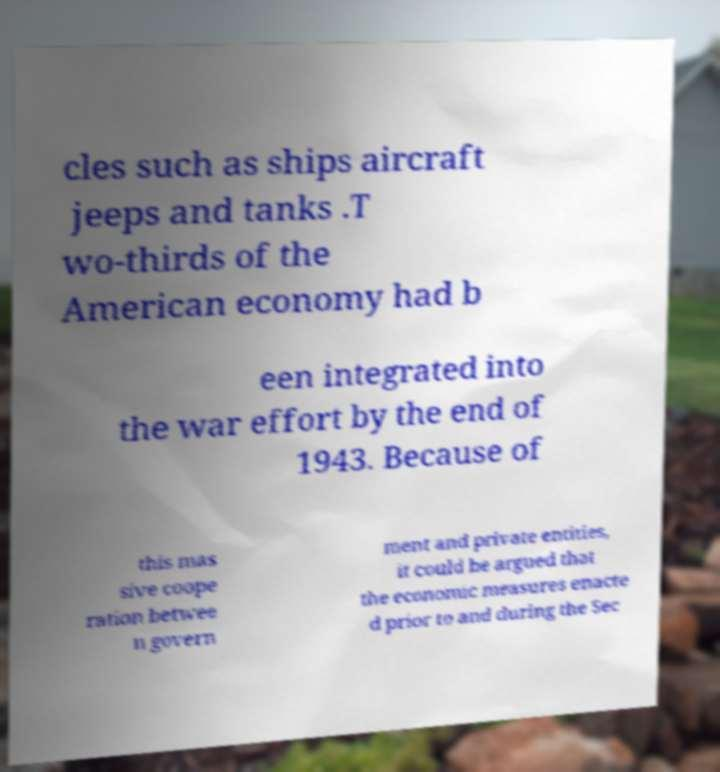Could you assist in decoding the text presented in this image and type it out clearly? cles such as ships aircraft jeeps and tanks .T wo-thirds of the American economy had b een integrated into the war effort by the end of 1943. Because of this mas sive coope ration betwee n govern ment and private entities, it could be argued that the economic measures enacte d prior to and during the Sec 